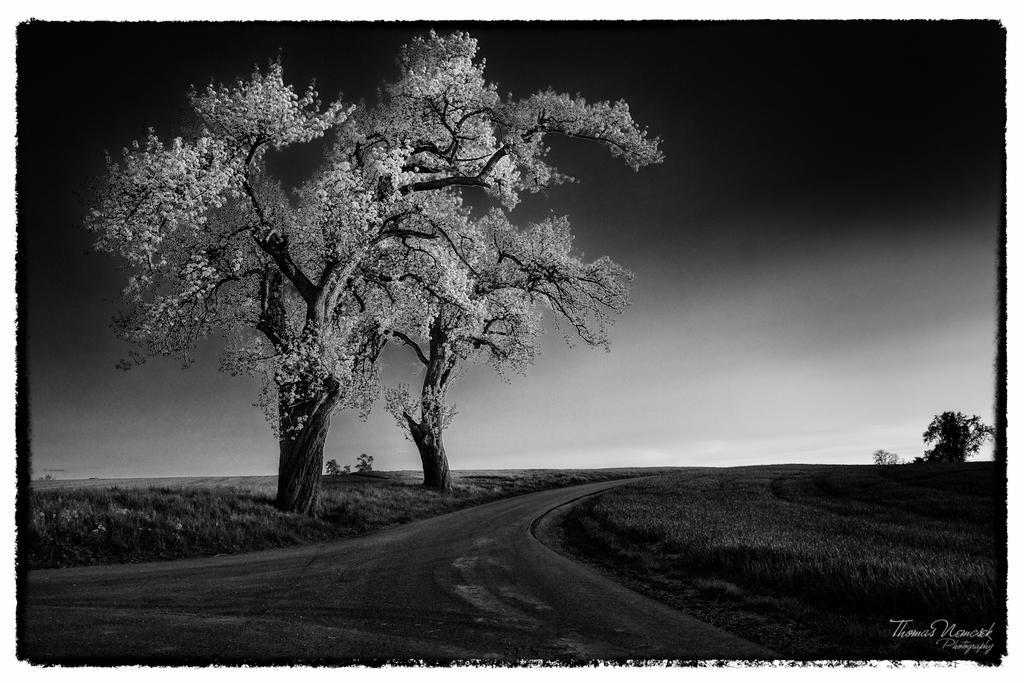How would you summarize this image in a sentence or two? It is a black and white image, in the middle there are trees. At the bottom it is the road. On the right side there is the grass, at the top it is the sky. 